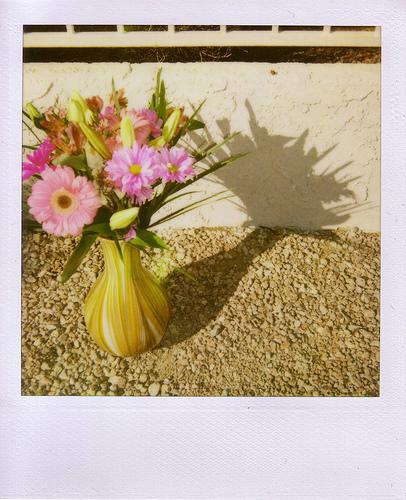Write a brief description focusing on colors and textures in the image. A vivid yellow vase with white patches holds soft pink flowers, resting on a bed of golden brown gravel, against a rough white cement wall. Describe the lighting and any shadows present in the image. Natural light subtly illuminates the yellow vase with pink flowers, casting soft shadows on the beige gravel and white cement wall in the background. How would an art critic describe the centerpiece of the image? A captivating still life featuring a vibrant yellow vase adorned with a bouquet of delicate pink flowers, set against a textured white wall. Describe the image as if you are talking to a child. Look, there's a pretty yellow vase with beautiful pink flowers, sitting on some small rocks, and there's a white wall and railing behind them. Describe the scene in the image as if you're writing a novel. Amidst an enchanting garden, a yellow vase with whimsical white patches gracefully holds a collection of blushing pink flowers, their soft petals whispering tales of love and beauty. Provide a concise description of the primary object in the image. A yellow vase filled with pink flowers, placed on beige gravel against a white cement wall. Mention the key elements in the image along with their positions. A yellow vase with pink flowers at the left-center, beige gravel below it, a white cement wall in the background, and a white railing above the wall. Enumerate the main elements in the image without using complete sentences. Yellow vase, pink flowers, beige gravel, white cement wall, white railing. Sum up the image in one sentence using simple words. There's a yellow vase with pink flowers on some beige gravel, with a white wall and railing behind it. Write a poetic description of the image. Amidst a serene oasis, a sun-kissed vase caressed with gentle shadows, cradles a bouquet of tender pink blooms, whispering sweet secrets of captured beauty and love. 